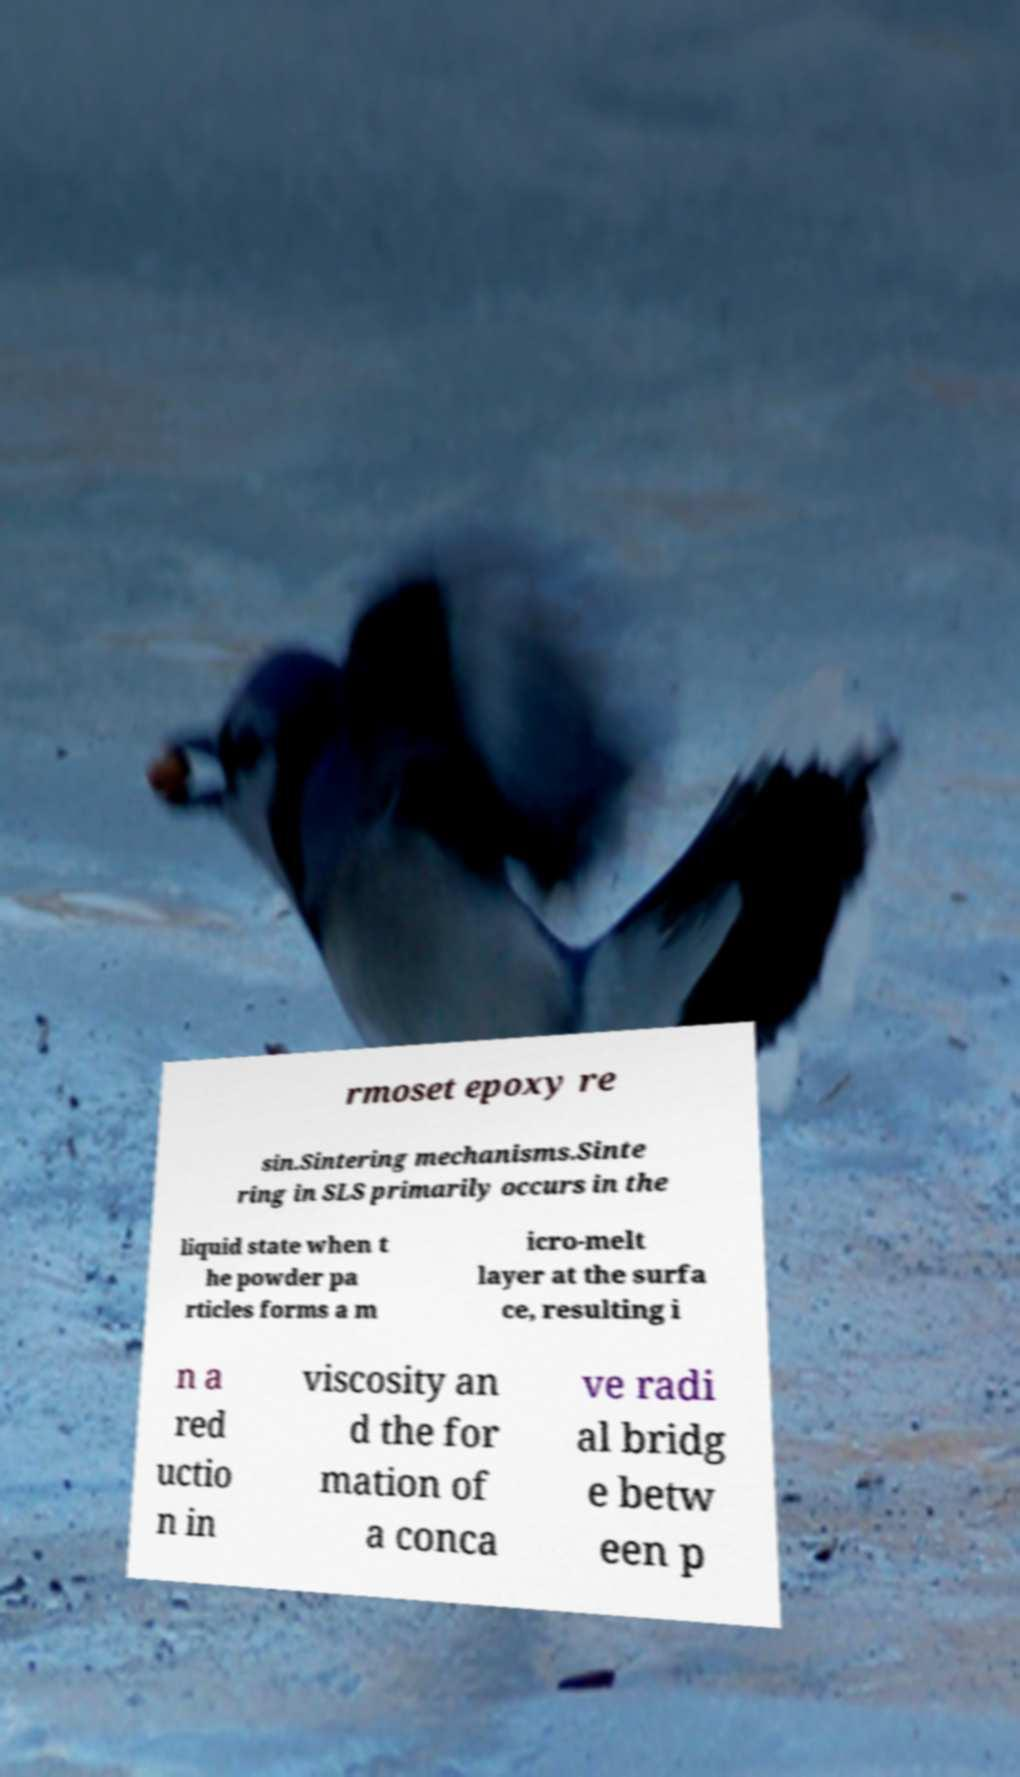There's text embedded in this image that I need extracted. Can you transcribe it verbatim? rmoset epoxy re sin.Sintering mechanisms.Sinte ring in SLS primarily occurs in the liquid state when t he powder pa rticles forms a m icro-melt layer at the surfa ce, resulting i n a red uctio n in viscosity an d the for mation of a conca ve radi al bridg e betw een p 